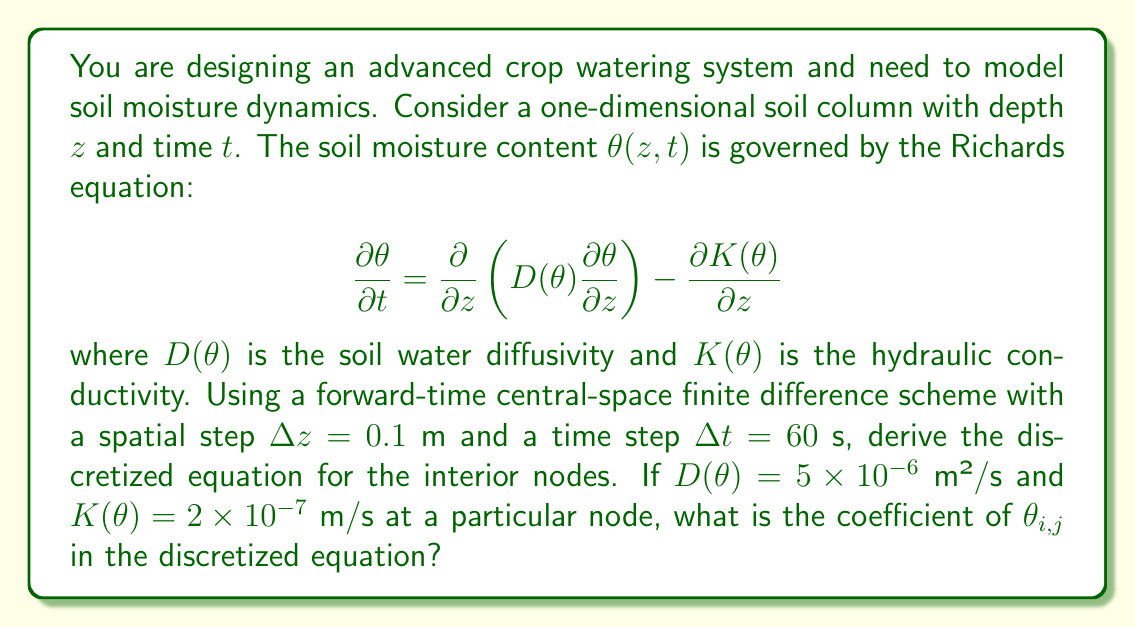Can you answer this question? Let's approach this step-by-step:

1) The Richards equation is given by:

   $$\frac{\partial \theta}{\partial t} = \frac{\partial}{\partial z}\left(D(\theta)\frac{\partial \theta}{\partial z}\right) - \frac{\partial K(\theta)}{\partial z}$$

2) We need to discretize this equation using forward-time central-space finite difference scheme. Let's break it down:

   a) $\frac{\partial \theta}{\partial t} \approx \frac{\theta_{i,j+1} - \theta_{i,j}}{\Delta t}$

   b) $\frac{\partial}{\partial z}\left(D(\theta)\frac{\partial \theta}{\partial z}\right) \approx \frac{D_{i+1/2}(\theta_{i+1,j} - \theta_{i,j}) - D_{i-1/2}(\theta_{i,j} - \theta_{i-1,j})}{(\Delta z)^2}$

   c) $\frac{\partial K(\theta)}{\partial z} \approx \frac{K_{i+1} - K_{i-1}}{2\Delta z}$

3) Substituting these approximations into the original equation:

   $$\frac{\theta_{i,j+1} - \theta_{i,j}}{\Delta t} = \frac{D_{i+1/2}(\theta_{i+1,j} - \theta_{i,j}) - D_{i-1/2}(\theta_{i,j} - \theta_{i-1,j})}{(\Delta z)^2} - \frac{K_{i+1} - K_{i-1}}{2\Delta z}$$

4) Rearranging to isolate $\theta_{i,j+1}$:

   $$\theta_{i,j+1} = \theta_{i,j} + \frac{\Delta t}{(\Delta z)^2}[D_{i+1/2}(\theta_{i+1,j} - \theta_{i,j}) - D_{i-1/2}(\theta_{i,j} - \theta_{i-1,j})] - \frac{\Delta t}{2\Delta z}(K_{i+1} - K_{i-1})$$

5) The coefficient of $\theta_{i,j}$ in this equation is:

   $$1 - \frac{\Delta t}{(\Delta z)^2}(D_{i+1/2} + D_{i-1/2})$$

6) Given $D(\theta) = 5 \times 10^{-6}$ m²/s, $\Delta z = 0.1$ m, and $\Delta t = 60$ s, we can calculate:

   $$1 - \frac{60}{(0.1)^2}(5 \times 10^{-6} + 5 \times 10^{-6}) = 1 - 0.06 = 0.94$$

Note that the value of $K(\theta)$ is not needed for this calculation.
Answer: 0.94 